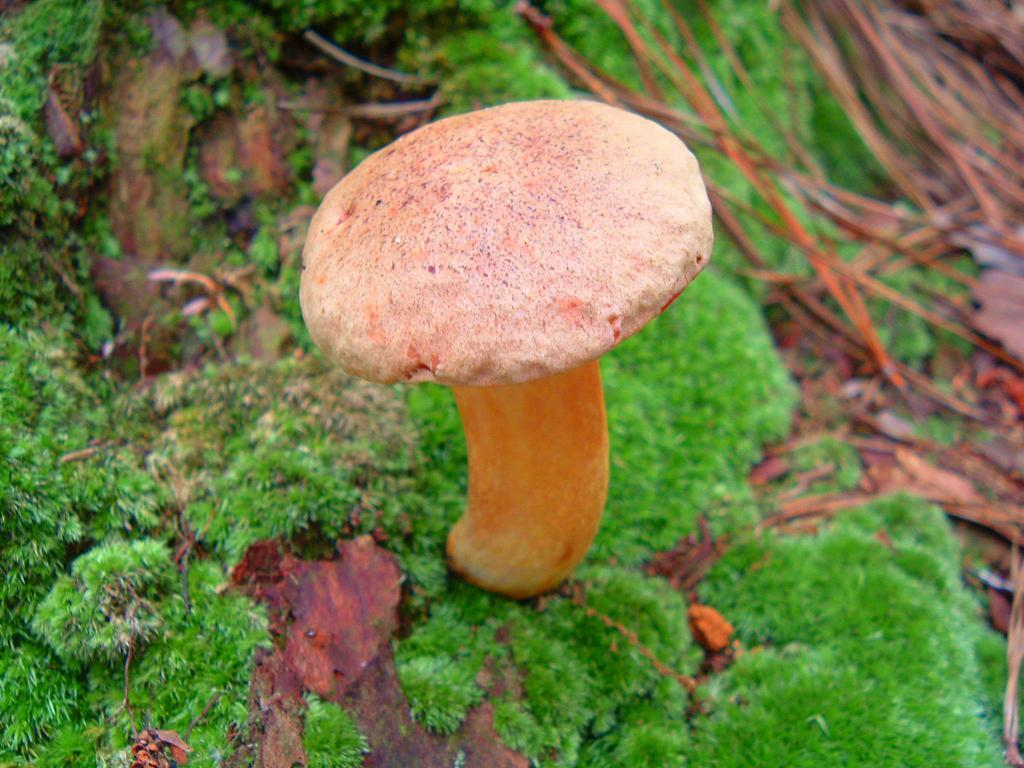What is on the ground in the image? There is a mushroom and grass on the ground. What else can be seen in the background of the image? In the background, there are threads on the ground and more grass. Can you hear the voice of the ghost in the image? There is no mention of a ghost or voice in the image, so it cannot be heard. Is there any magic happening in the image? There is no mention of magic in the image, so it cannot be observed. 